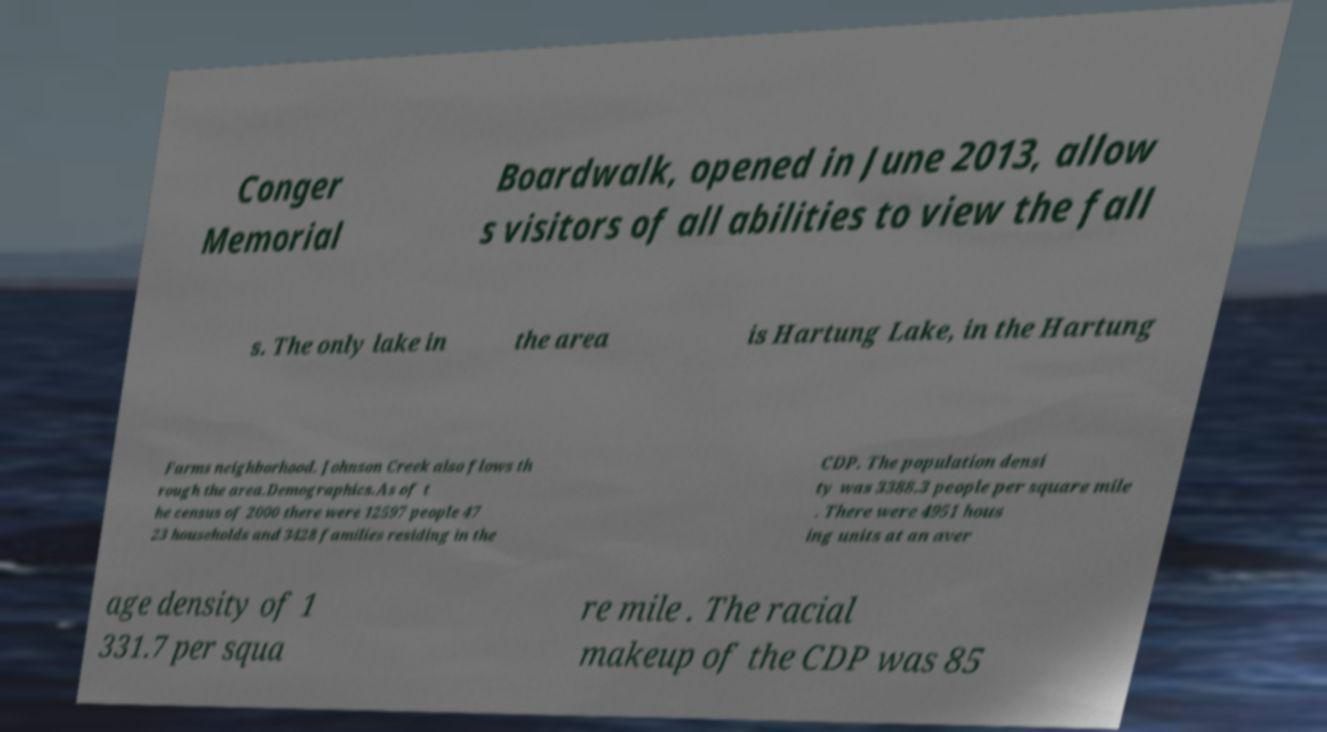Please identify and transcribe the text found in this image. Conger Memorial Boardwalk, opened in June 2013, allow s visitors of all abilities to view the fall s. The only lake in the area is Hartung Lake, in the Hartung Farms neighborhood. Johnson Creek also flows th rough the area.Demographics.As of t he census of 2000 there were 12597 people 47 23 households and 3428 families residing in the CDP. The population densi ty was 3388.3 people per square mile . There were 4951 hous ing units at an aver age density of 1 331.7 per squa re mile . The racial makeup of the CDP was 85 